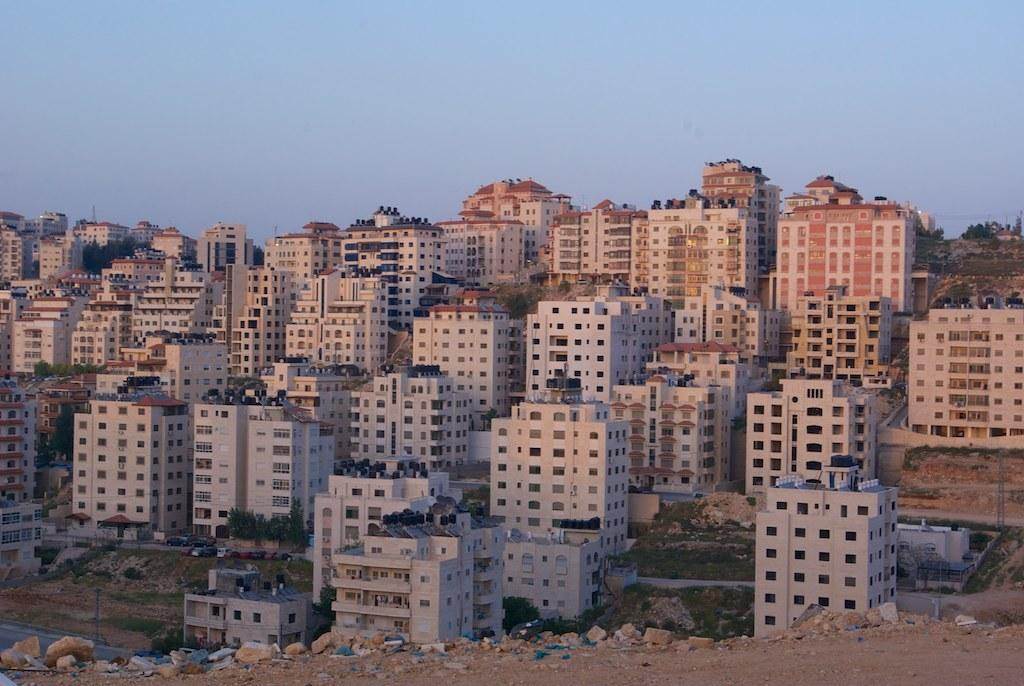What is the main focus of the image? The main focus of the image is the buildings in the center. What other structures or elements can be seen in the image? There is a wall, a roof, windows, trees, poles, stones, grass, a road, and sky visible in the image. Are there any people present in the image? Yes, there is a group of people standing on the buildings. What type of surface is visible on the ground? The ground has grass and stones. What type of wood is being used to push the buildings in the image? There is no wood or pushing action involving the buildings in the image. 